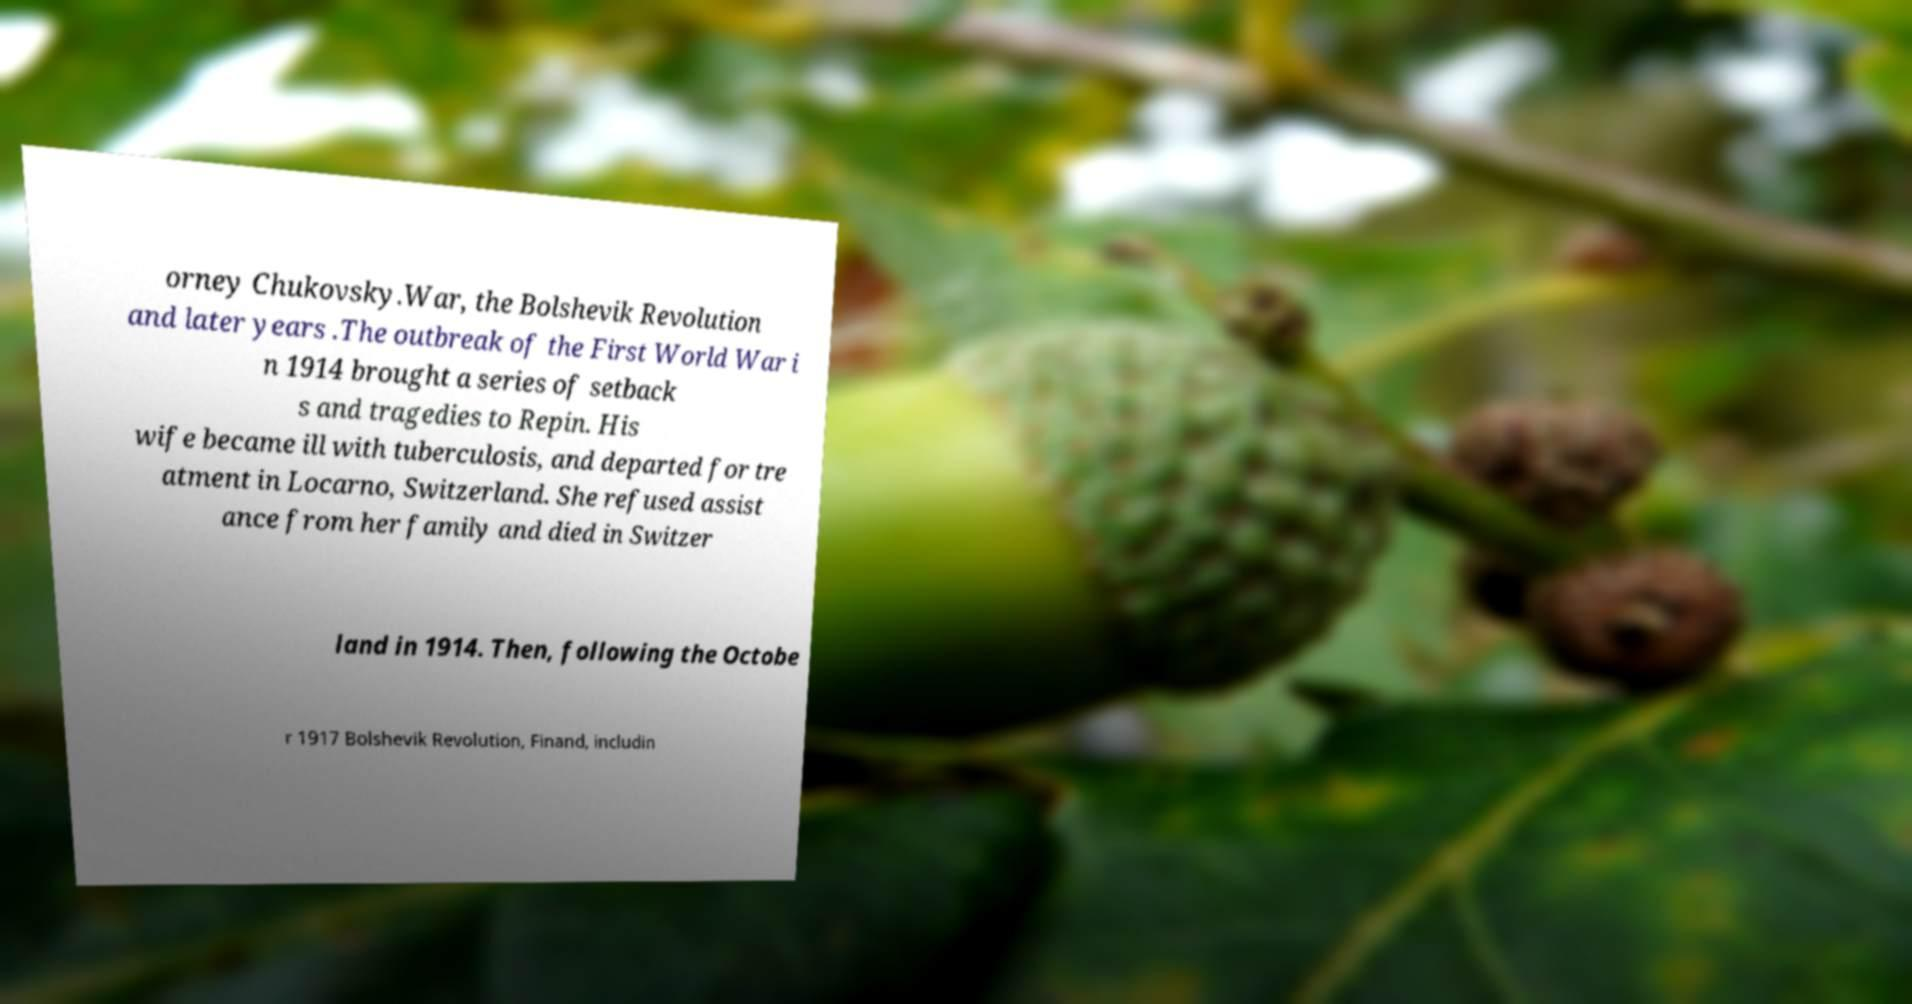Can you read and provide the text displayed in the image?This photo seems to have some interesting text. Can you extract and type it out for me? orney Chukovsky.War, the Bolshevik Revolution and later years .The outbreak of the First World War i n 1914 brought a series of setback s and tragedies to Repin. His wife became ill with tuberculosis, and departed for tre atment in Locarno, Switzerland. She refused assist ance from her family and died in Switzer land in 1914. Then, following the Octobe r 1917 Bolshevik Revolution, Finand, includin 